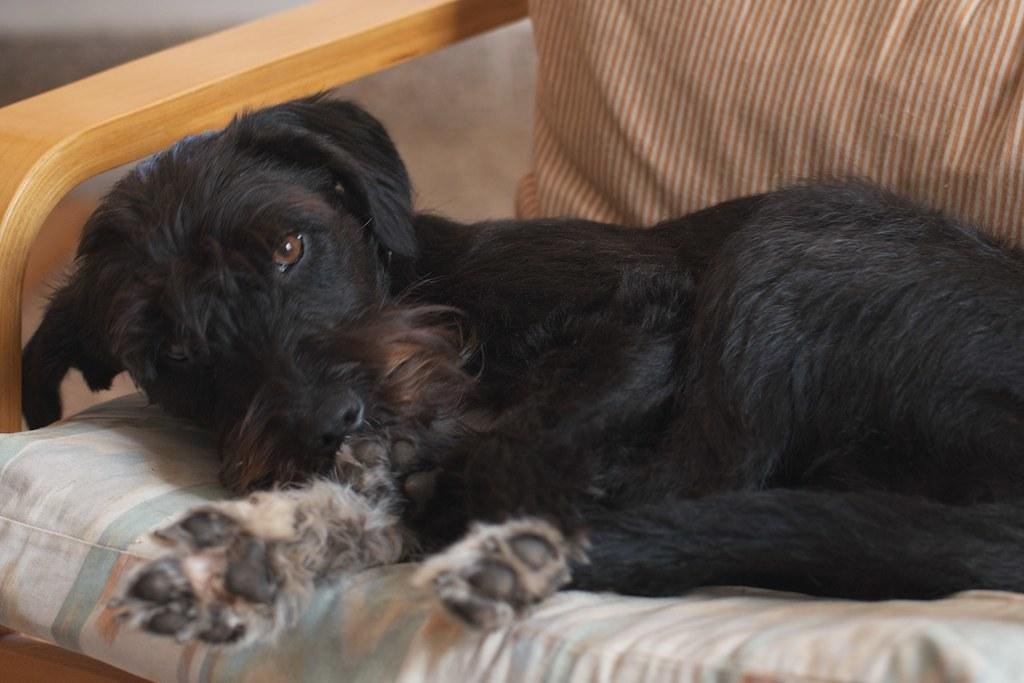What type of animal is on the bed in the image? There is a dog on the bed in the image. Can you describe the setting where the dog is located? The dog is on a bed, which suggests it might be in a bedroom or similar setting. Is there any indication of a person being present in the image? There may be a person behind the dog in the image, but it is not clearly visible. What type of badge does the dog's owner wear in the image? There is no dog owner or badge present in the image. Is the dog in jail in the image? There is no indication of a jail or any confinement in the image; it simply shows a dog on a bed. 